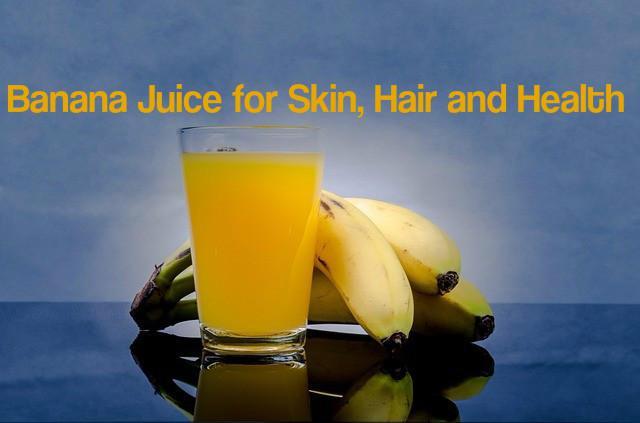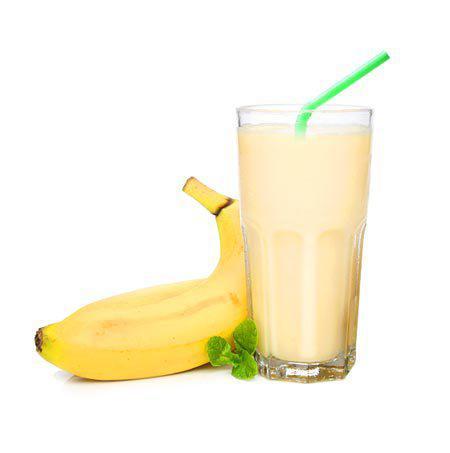The first image is the image on the left, the second image is the image on the right. Evaluate the accuracy of this statement regarding the images: "The glass in the image to the right, it has a straw in it.". Is it true? Answer yes or no. Yes. The first image is the image on the left, the second image is the image on the right. Evaluate the accuracy of this statement regarding the images: "there is a glass of banana smoothie with a straw and at least 4 whole bananas next to it". Is it true? Answer yes or no. No. 